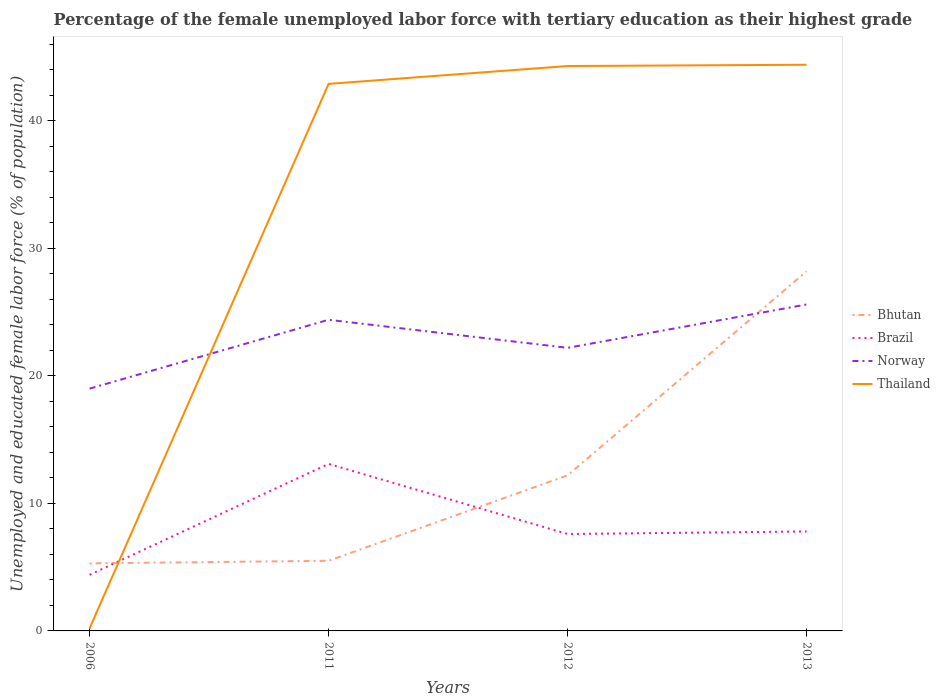Is the number of lines equal to the number of legend labels?
Provide a succinct answer. Yes. Across all years, what is the maximum percentage of the unemployed female labor force with tertiary education in Thailand?
Make the answer very short. 0.2. In which year was the percentage of the unemployed female labor force with tertiary education in Norway maximum?
Keep it short and to the point. 2006. What is the total percentage of the unemployed female labor force with tertiary education in Brazil in the graph?
Provide a short and direct response. -0.2. What is the difference between the highest and the second highest percentage of the unemployed female labor force with tertiary education in Brazil?
Offer a terse response. 8.7. How many lines are there?
Make the answer very short. 4. How many years are there in the graph?
Your answer should be very brief. 4. Are the values on the major ticks of Y-axis written in scientific E-notation?
Give a very brief answer. No. Does the graph contain any zero values?
Make the answer very short. No. Does the graph contain grids?
Your answer should be very brief. No. How are the legend labels stacked?
Provide a succinct answer. Vertical. What is the title of the graph?
Your answer should be very brief. Percentage of the female unemployed labor force with tertiary education as their highest grade. Does "Virgin Islands" appear as one of the legend labels in the graph?
Offer a terse response. No. What is the label or title of the Y-axis?
Offer a terse response. Unemployed and educated female labor force (% of population). What is the Unemployed and educated female labor force (% of population) of Bhutan in 2006?
Make the answer very short. 5.3. What is the Unemployed and educated female labor force (% of population) in Brazil in 2006?
Keep it short and to the point. 4.4. What is the Unemployed and educated female labor force (% of population) of Thailand in 2006?
Offer a terse response. 0.2. What is the Unemployed and educated female labor force (% of population) of Brazil in 2011?
Your answer should be very brief. 13.1. What is the Unemployed and educated female labor force (% of population) in Norway in 2011?
Keep it short and to the point. 24.4. What is the Unemployed and educated female labor force (% of population) in Thailand in 2011?
Give a very brief answer. 42.9. What is the Unemployed and educated female labor force (% of population) in Bhutan in 2012?
Offer a terse response. 12.2. What is the Unemployed and educated female labor force (% of population) in Brazil in 2012?
Offer a very short reply. 7.6. What is the Unemployed and educated female labor force (% of population) of Norway in 2012?
Your answer should be compact. 22.2. What is the Unemployed and educated female labor force (% of population) in Thailand in 2012?
Your response must be concise. 44.3. What is the Unemployed and educated female labor force (% of population) in Bhutan in 2013?
Your answer should be very brief. 28.2. What is the Unemployed and educated female labor force (% of population) in Brazil in 2013?
Provide a short and direct response. 7.8. What is the Unemployed and educated female labor force (% of population) of Norway in 2013?
Your response must be concise. 25.6. What is the Unemployed and educated female labor force (% of population) in Thailand in 2013?
Give a very brief answer. 44.4. Across all years, what is the maximum Unemployed and educated female labor force (% of population) of Bhutan?
Offer a very short reply. 28.2. Across all years, what is the maximum Unemployed and educated female labor force (% of population) of Brazil?
Make the answer very short. 13.1. Across all years, what is the maximum Unemployed and educated female labor force (% of population) of Norway?
Your answer should be very brief. 25.6. Across all years, what is the maximum Unemployed and educated female labor force (% of population) in Thailand?
Your answer should be compact. 44.4. Across all years, what is the minimum Unemployed and educated female labor force (% of population) of Bhutan?
Your answer should be compact. 5.3. Across all years, what is the minimum Unemployed and educated female labor force (% of population) in Brazil?
Your answer should be compact. 4.4. Across all years, what is the minimum Unemployed and educated female labor force (% of population) in Thailand?
Make the answer very short. 0.2. What is the total Unemployed and educated female labor force (% of population) in Bhutan in the graph?
Offer a very short reply. 51.2. What is the total Unemployed and educated female labor force (% of population) in Brazil in the graph?
Give a very brief answer. 32.9. What is the total Unemployed and educated female labor force (% of population) in Norway in the graph?
Offer a very short reply. 91.2. What is the total Unemployed and educated female labor force (% of population) of Thailand in the graph?
Your answer should be very brief. 131.8. What is the difference between the Unemployed and educated female labor force (% of population) in Thailand in 2006 and that in 2011?
Your answer should be very brief. -42.7. What is the difference between the Unemployed and educated female labor force (% of population) in Bhutan in 2006 and that in 2012?
Keep it short and to the point. -6.9. What is the difference between the Unemployed and educated female labor force (% of population) of Brazil in 2006 and that in 2012?
Make the answer very short. -3.2. What is the difference between the Unemployed and educated female labor force (% of population) in Thailand in 2006 and that in 2012?
Your response must be concise. -44.1. What is the difference between the Unemployed and educated female labor force (% of population) of Bhutan in 2006 and that in 2013?
Provide a short and direct response. -22.9. What is the difference between the Unemployed and educated female labor force (% of population) in Brazil in 2006 and that in 2013?
Keep it short and to the point. -3.4. What is the difference between the Unemployed and educated female labor force (% of population) of Thailand in 2006 and that in 2013?
Keep it short and to the point. -44.2. What is the difference between the Unemployed and educated female labor force (% of population) of Norway in 2011 and that in 2012?
Provide a short and direct response. 2.2. What is the difference between the Unemployed and educated female labor force (% of population) of Bhutan in 2011 and that in 2013?
Give a very brief answer. -22.7. What is the difference between the Unemployed and educated female labor force (% of population) of Brazil in 2011 and that in 2013?
Offer a terse response. 5.3. What is the difference between the Unemployed and educated female labor force (% of population) of Norway in 2011 and that in 2013?
Give a very brief answer. -1.2. What is the difference between the Unemployed and educated female labor force (% of population) in Bhutan in 2012 and that in 2013?
Ensure brevity in your answer.  -16. What is the difference between the Unemployed and educated female labor force (% of population) in Norway in 2012 and that in 2013?
Offer a very short reply. -3.4. What is the difference between the Unemployed and educated female labor force (% of population) in Bhutan in 2006 and the Unemployed and educated female labor force (% of population) in Norway in 2011?
Give a very brief answer. -19.1. What is the difference between the Unemployed and educated female labor force (% of population) in Bhutan in 2006 and the Unemployed and educated female labor force (% of population) in Thailand in 2011?
Your response must be concise. -37.6. What is the difference between the Unemployed and educated female labor force (% of population) of Brazil in 2006 and the Unemployed and educated female labor force (% of population) of Norway in 2011?
Your response must be concise. -20. What is the difference between the Unemployed and educated female labor force (% of population) in Brazil in 2006 and the Unemployed and educated female labor force (% of population) in Thailand in 2011?
Provide a short and direct response. -38.5. What is the difference between the Unemployed and educated female labor force (% of population) of Norway in 2006 and the Unemployed and educated female labor force (% of population) of Thailand in 2011?
Your response must be concise. -23.9. What is the difference between the Unemployed and educated female labor force (% of population) of Bhutan in 2006 and the Unemployed and educated female labor force (% of population) of Norway in 2012?
Offer a very short reply. -16.9. What is the difference between the Unemployed and educated female labor force (% of population) of Bhutan in 2006 and the Unemployed and educated female labor force (% of population) of Thailand in 2012?
Offer a terse response. -39. What is the difference between the Unemployed and educated female labor force (% of population) in Brazil in 2006 and the Unemployed and educated female labor force (% of population) in Norway in 2012?
Give a very brief answer. -17.8. What is the difference between the Unemployed and educated female labor force (% of population) of Brazil in 2006 and the Unemployed and educated female labor force (% of population) of Thailand in 2012?
Your answer should be compact. -39.9. What is the difference between the Unemployed and educated female labor force (% of population) in Norway in 2006 and the Unemployed and educated female labor force (% of population) in Thailand in 2012?
Give a very brief answer. -25.3. What is the difference between the Unemployed and educated female labor force (% of population) in Bhutan in 2006 and the Unemployed and educated female labor force (% of population) in Brazil in 2013?
Your response must be concise. -2.5. What is the difference between the Unemployed and educated female labor force (% of population) of Bhutan in 2006 and the Unemployed and educated female labor force (% of population) of Norway in 2013?
Provide a short and direct response. -20.3. What is the difference between the Unemployed and educated female labor force (% of population) of Bhutan in 2006 and the Unemployed and educated female labor force (% of population) of Thailand in 2013?
Offer a terse response. -39.1. What is the difference between the Unemployed and educated female labor force (% of population) of Brazil in 2006 and the Unemployed and educated female labor force (% of population) of Norway in 2013?
Your answer should be very brief. -21.2. What is the difference between the Unemployed and educated female labor force (% of population) in Norway in 2006 and the Unemployed and educated female labor force (% of population) in Thailand in 2013?
Keep it short and to the point. -25.4. What is the difference between the Unemployed and educated female labor force (% of population) in Bhutan in 2011 and the Unemployed and educated female labor force (% of population) in Norway in 2012?
Offer a very short reply. -16.7. What is the difference between the Unemployed and educated female labor force (% of population) in Bhutan in 2011 and the Unemployed and educated female labor force (% of population) in Thailand in 2012?
Your response must be concise. -38.8. What is the difference between the Unemployed and educated female labor force (% of population) of Brazil in 2011 and the Unemployed and educated female labor force (% of population) of Thailand in 2012?
Your answer should be compact. -31.2. What is the difference between the Unemployed and educated female labor force (% of population) in Norway in 2011 and the Unemployed and educated female labor force (% of population) in Thailand in 2012?
Offer a very short reply. -19.9. What is the difference between the Unemployed and educated female labor force (% of population) in Bhutan in 2011 and the Unemployed and educated female labor force (% of population) in Norway in 2013?
Ensure brevity in your answer.  -20.1. What is the difference between the Unemployed and educated female labor force (% of population) in Bhutan in 2011 and the Unemployed and educated female labor force (% of population) in Thailand in 2013?
Offer a terse response. -38.9. What is the difference between the Unemployed and educated female labor force (% of population) in Brazil in 2011 and the Unemployed and educated female labor force (% of population) in Norway in 2013?
Keep it short and to the point. -12.5. What is the difference between the Unemployed and educated female labor force (% of population) in Brazil in 2011 and the Unemployed and educated female labor force (% of population) in Thailand in 2013?
Offer a terse response. -31.3. What is the difference between the Unemployed and educated female labor force (% of population) in Norway in 2011 and the Unemployed and educated female labor force (% of population) in Thailand in 2013?
Make the answer very short. -20. What is the difference between the Unemployed and educated female labor force (% of population) of Bhutan in 2012 and the Unemployed and educated female labor force (% of population) of Brazil in 2013?
Offer a very short reply. 4.4. What is the difference between the Unemployed and educated female labor force (% of population) in Bhutan in 2012 and the Unemployed and educated female labor force (% of population) in Norway in 2013?
Ensure brevity in your answer.  -13.4. What is the difference between the Unemployed and educated female labor force (% of population) in Bhutan in 2012 and the Unemployed and educated female labor force (% of population) in Thailand in 2013?
Provide a short and direct response. -32.2. What is the difference between the Unemployed and educated female labor force (% of population) of Brazil in 2012 and the Unemployed and educated female labor force (% of population) of Thailand in 2013?
Offer a terse response. -36.8. What is the difference between the Unemployed and educated female labor force (% of population) of Norway in 2012 and the Unemployed and educated female labor force (% of population) of Thailand in 2013?
Offer a terse response. -22.2. What is the average Unemployed and educated female labor force (% of population) of Bhutan per year?
Your response must be concise. 12.8. What is the average Unemployed and educated female labor force (% of population) in Brazil per year?
Make the answer very short. 8.22. What is the average Unemployed and educated female labor force (% of population) in Norway per year?
Your answer should be compact. 22.8. What is the average Unemployed and educated female labor force (% of population) in Thailand per year?
Ensure brevity in your answer.  32.95. In the year 2006, what is the difference between the Unemployed and educated female labor force (% of population) of Bhutan and Unemployed and educated female labor force (% of population) of Brazil?
Your answer should be compact. 0.9. In the year 2006, what is the difference between the Unemployed and educated female labor force (% of population) of Bhutan and Unemployed and educated female labor force (% of population) of Norway?
Your answer should be compact. -13.7. In the year 2006, what is the difference between the Unemployed and educated female labor force (% of population) in Bhutan and Unemployed and educated female labor force (% of population) in Thailand?
Your answer should be compact. 5.1. In the year 2006, what is the difference between the Unemployed and educated female labor force (% of population) in Brazil and Unemployed and educated female labor force (% of population) in Norway?
Provide a short and direct response. -14.6. In the year 2011, what is the difference between the Unemployed and educated female labor force (% of population) of Bhutan and Unemployed and educated female labor force (% of population) of Norway?
Offer a very short reply. -18.9. In the year 2011, what is the difference between the Unemployed and educated female labor force (% of population) of Bhutan and Unemployed and educated female labor force (% of population) of Thailand?
Provide a short and direct response. -37.4. In the year 2011, what is the difference between the Unemployed and educated female labor force (% of population) of Brazil and Unemployed and educated female labor force (% of population) of Norway?
Your answer should be compact. -11.3. In the year 2011, what is the difference between the Unemployed and educated female labor force (% of population) in Brazil and Unemployed and educated female labor force (% of population) in Thailand?
Offer a terse response. -29.8. In the year 2011, what is the difference between the Unemployed and educated female labor force (% of population) of Norway and Unemployed and educated female labor force (% of population) of Thailand?
Give a very brief answer. -18.5. In the year 2012, what is the difference between the Unemployed and educated female labor force (% of population) of Bhutan and Unemployed and educated female labor force (% of population) of Norway?
Make the answer very short. -10. In the year 2012, what is the difference between the Unemployed and educated female labor force (% of population) of Bhutan and Unemployed and educated female labor force (% of population) of Thailand?
Keep it short and to the point. -32.1. In the year 2012, what is the difference between the Unemployed and educated female labor force (% of population) in Brazil and Unemployed and educated female labor force (% of population) in Norway?
Provide a succinct answer. -14.6. In the year 2012, what is the difference between the Unemployed and educated female labor force (% of population) of Brazil and Unemployed and educated female labor force (% of population) of Thailand?
Your answer should be very brief. -36.7. In the year 2012, what is the difference between the Unemployed and educated female labor force (% of population) in Norway and Unemployed and educated female labor force (% of population) in Thailand?
Provide a short and direct response. -22.1. In the year 2013, what is the difference between the Unemployed and educated female labor force (% of population) in Bhutan and Unemployed and educated female labor force (% of population) in Brazil?
Ensure brevity in your answer.  20.4. In the year 2013, what is the difference between the Unemployed and educated female labor force (% of population) in Bhutan and Unemployed and educated female labor force (% of population) in Norway?
Provide a short and direct response. 2.6. In the year 2013, what is the difference between the Unemployed and educated female labor force (% of population) in Bhutan and Unemployed and educated female labor force (% of population) in Thailand?
Give a very brief answer. -16.2. In the year 2013, what is the difference between the Unemployed and educated female labor force (% of population) of Brazil and Unemployed and educated female labor force (% of population) of Norway?
Offer a very short reply. -17.8. In the year 2013, what is the difference between the Unemployed and educated female labor force (% of population) of Brazil and Unemployed and educated female labor force (% of population) of Thailand?
Offer a very short reply. -36.6. In the year 2013, what is the difference between the Unemployed and educated female labor force (% of population) in Norway and Unemployed and educated female labor force (% of population) in Thailand?
Your response must be concise. -18.8. What is the ratio of the Unemployed and educated female labor force (% of population) in Bhutan in 2006 to that in 2011?
Your answer should be compact. 0.96. What is the ratio of the Unemployed and educated female labor force (% of population) in Brazil in 2006 to that in 2011?
Offer a terse response. 0.34. What is the ratio of the Unemployed and educated female labor force (% of population) in Norway in 2006 to that in 2011?
Offer a terse response. 0.78. What is the ratio of the Unemployed and educated female labor force (% of population) in Thailand in 2006 to that in 2011?
Make the answer very short. 0. What is the ratio of the Unemployed and educated female labor force (% of population) in Bhutan in 2006 to that in 2012?
Give a very brief answer. 0.43. What is the ratio of the Unemployed and educated female labor force (% of population) in Brazil in 2006 to that in 2012?
Keep it short and to the point. 0.58. What is the ratio of the Unemployed and educated female labor force (% of population) in Norway in 2006 to that in 2012?
Your response must be concise. 0.86. What is the ratio of the Unemployed and educated female labor force (% of population) in Thailand in 2006 to that in 2012?
Give a very brief answer. 0. What is the ratio of the Unemployed and educated female labor force (% of population) of Bhutan in 2006 to that in 2013?
Provide a short and direct response. 0.19. What is the ratio of the Unemployed and educated female labor force (% of population) in Brazil in 2006 to that in 2013?
Keep it short and to the point. 0.56. What is the ratio of the Unemployed and educated female labor force (% of population) in Norway in 2006 to that in 2013?
Keep it short and to the point. 0.74. What is the ratio of the Unemployed and educated female labor force (% of population) in Thailand in 2006 to that in 2013?
Give a very brief answer. 0. What is the ratio of the Unemployed and educated female labor force (% of population) of Bhutan in 2011 to that in 2012?
Ensure brevity in your answer.  0.45. What is the ratio of the Unemployed and educated female labor force (% of population) in Brazil in 2011 to that in 2012?
Your answer should be compact. 1.72. What is the ratio of the Unemployed and educated female labor force (% of population) of Norway in 2011 to that in 2012?
Offer a terse response. 1.1. What is the ratio of the Unemployed and educated female labor force (% of population) of Thailand in 2011 to that in 2012?
Ensure brevity in your answer.  0.97. What is the ratio of the Unemployed and educated female labor force (% of population) of Bhutan in 2011 to that in 2013?
Keep it short and to the point. 0.2. What is the ratio of the Unemployed and educated female labor force (% of population) of Brazil in 2011 to that in 2013?
Provide a succinct answer. 1.68. What is the ratio of the Unemployed and educated female labor force (% of population) in Norway in 2011 to that in 2013?
Your answer should be very brief. 0.95. What is the ratio of the Unemployed and educated female labor force (% of population) of Thailand in 2011 to that in 2013?
Provide a succinct answer. 0.97. What is the ratio of the Unemployed and educated female labor force (% of population) of Bhutan in 2012 to that in 2013?
Provide a succinct answer. 0.43. What is the ratio of the Unemployed and educated female labor force (% of population) in Brazil in 2012 to that in 2013?
Make the answer very short. 0.97. What is the ratio of the Unemployed and educated female labor force (% of population) in Norway in 2012 to that in 2013?
Ensure brevity in your answer.  0.87. What is the ratio of the Unemployed and educated female labor force (% of population) of Thailand in 2012 to that in 2013?
Your answer should be very brief. 1. What is the difference between the highest and the second highest Unemployed and educated female labor force (% of population) of Thailand?
Offer a very short reply. 0.1. What is the difference between the highest and the lowest Unemployed and educated female labor force (% of population) in Bhutan?
Provide a short and direct response. 22.9. What is the difference between the highest and the lowest Unemployed and educated female labor force (% of population) in Norway?
Provide a short and direct response. 6.6. What is the difference between the highest and the lowest Unemployed and educated female labor force (% of population) of Thailand?
Your response must be concise. 44.2. 